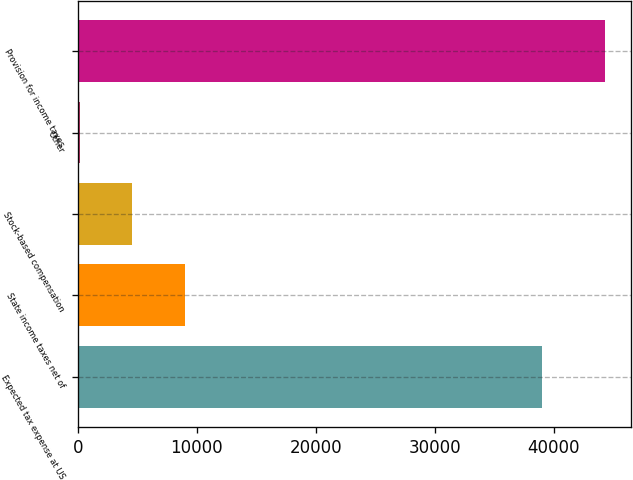Convert chart to OTSL. <chart><loc_0><loc_0><loc_500><loc_500><bar_chart><fcel>Expected tax expense at US<fcel>State income taxes net of<fcel>Stock-based compensation<fcel>Other<fcel>Provision for income taxes<nl><fcel>39025<fcel>9021.8<fcel>4609.9<fcel>198<fcel>44317<nl></chart> 